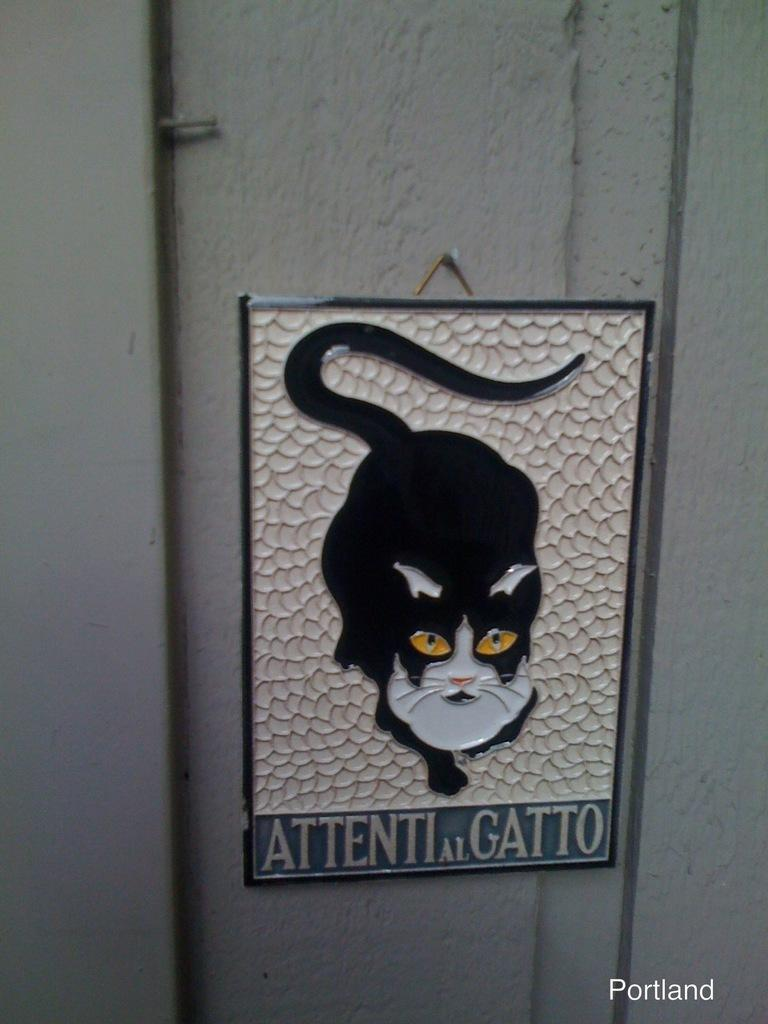What is on the wall in the image? There is a board on the wall in the image. What is depicted on the board? There is a picture of a cat on the board. What else is on the board besides the cat picture? There is text on the board. Where can additional text be found in the image? There is text in the bottom right side of the image. What type of honey is being used to write the text in the image? There is no honey present in the image; the text is written using a different medium, likely ink or paint. 